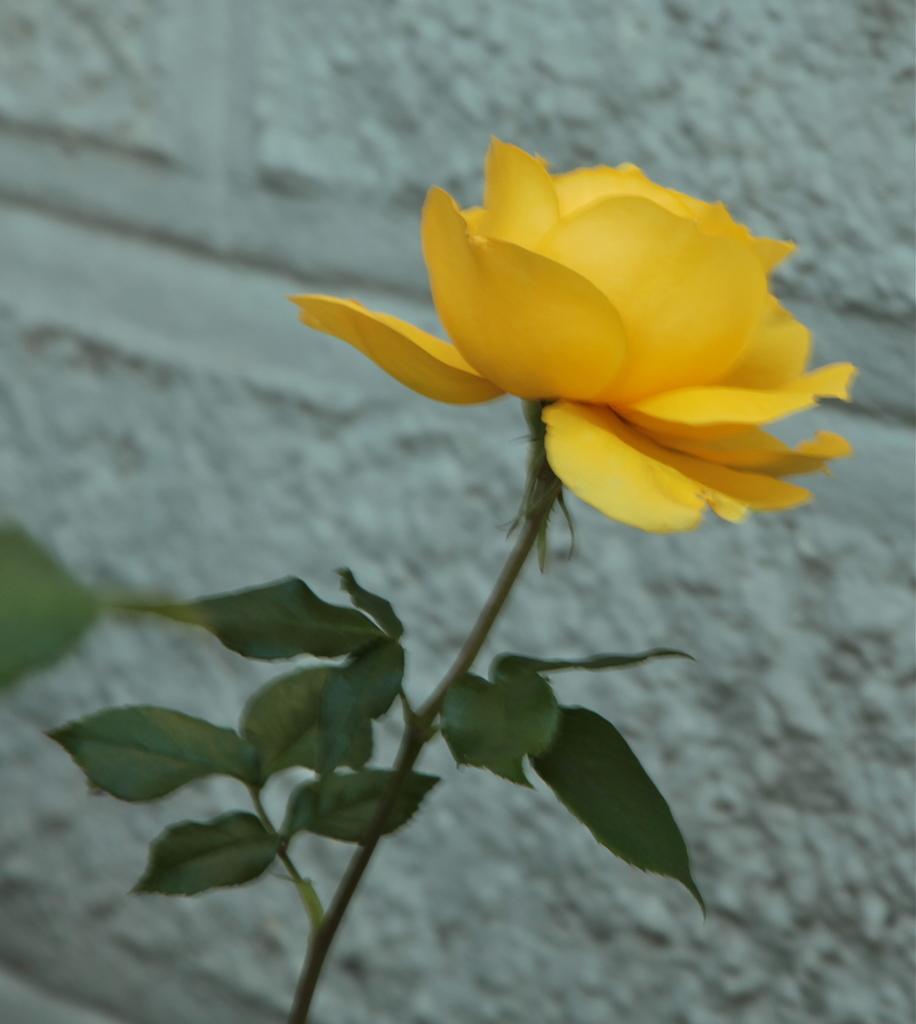Please provide a concise description of this image. In this image I can see a flower which is yellow in color and few leaves of the tree which are green in color. In the background I can see the wall which is white in color. 